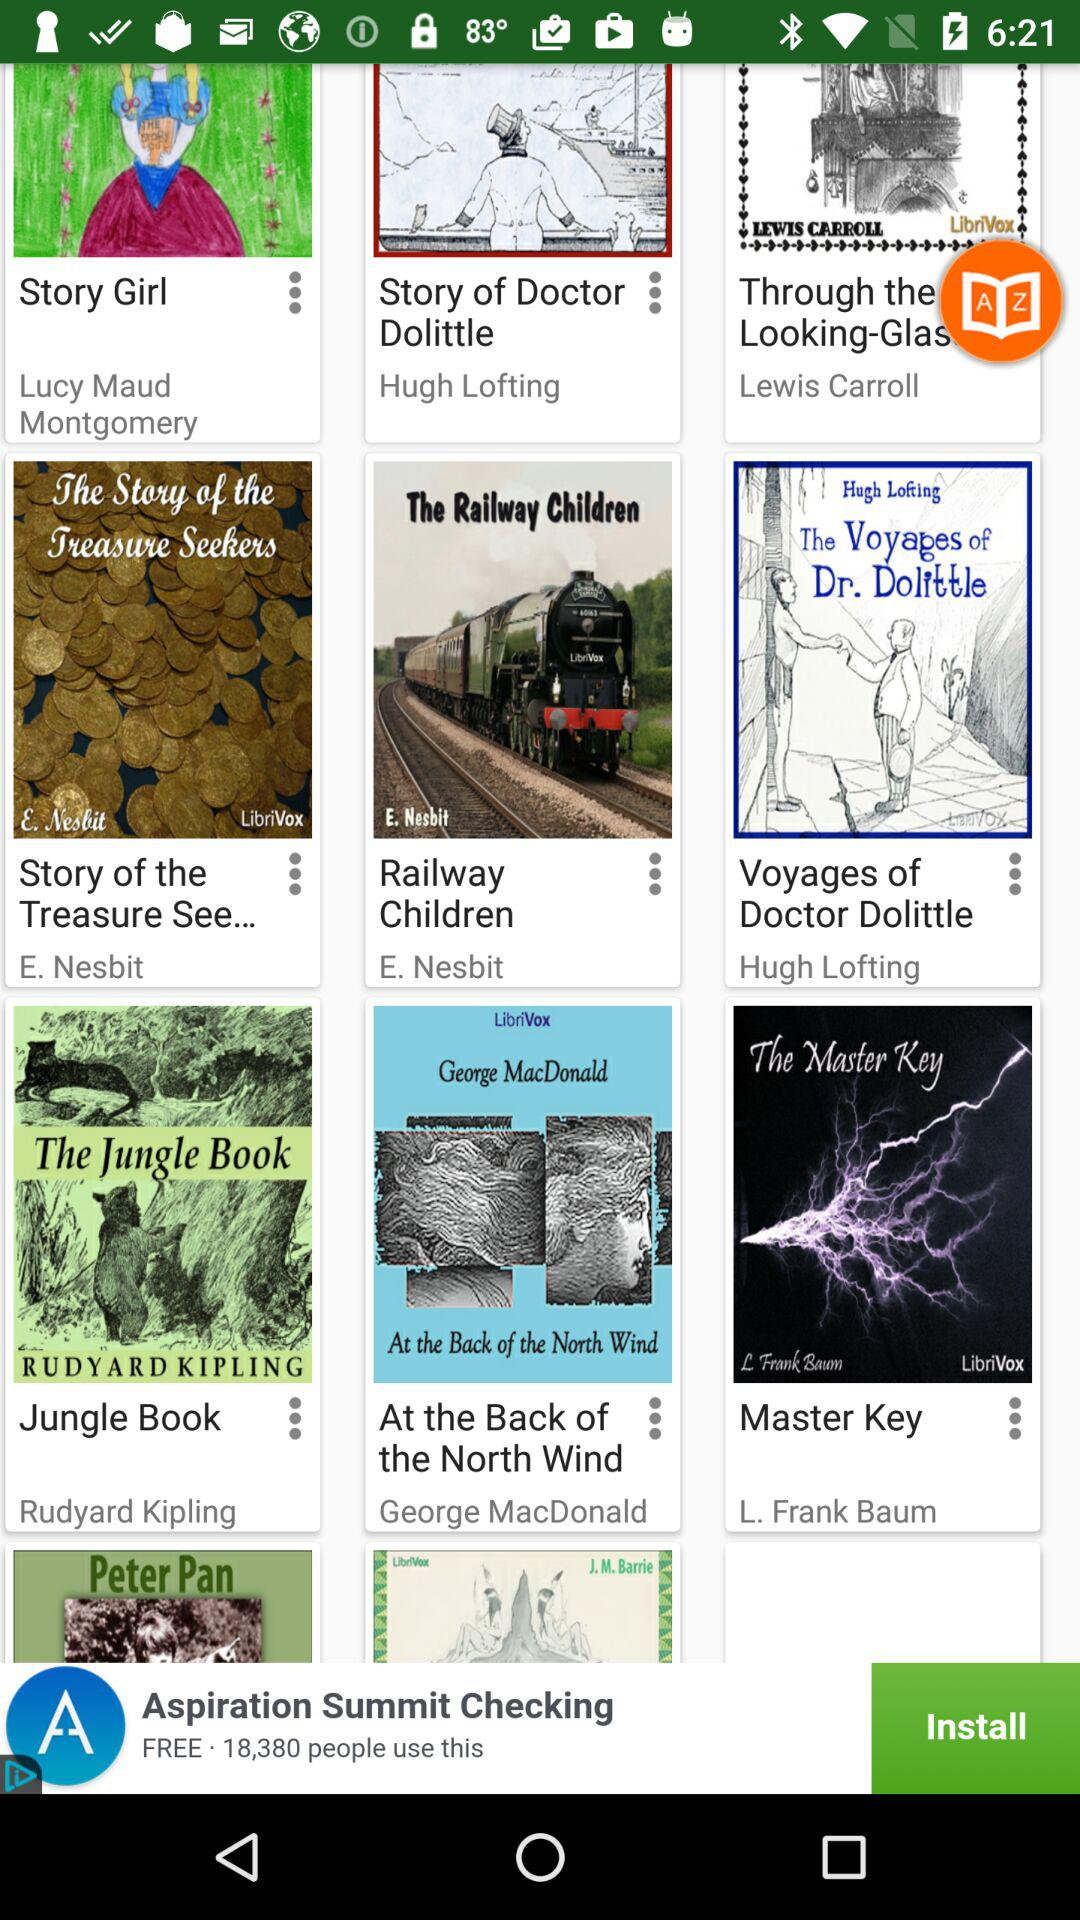Which book is written by the author Lewis Carroll?
When the provided information is insufficient, respond with <no answer>. <no answer> 